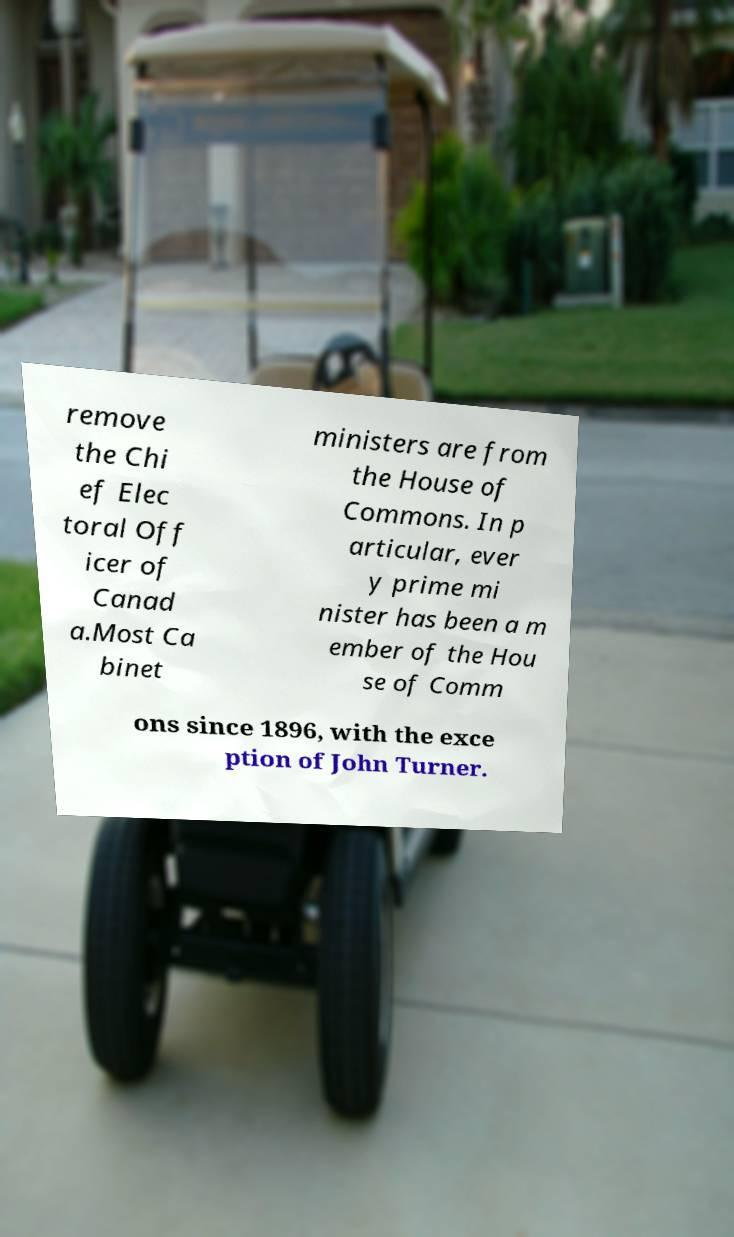For documentation purposes, I need the text within this image transcribed. Could you provide that? remove the Chi ef Elec toral Off icer of Canad a.Most Ca binet ministers are from the House of Commons. In p articular, ever y prime mi nister has been a m ember of the Hou se of Comm ons since 1896, with the exce ption of John Turner. 